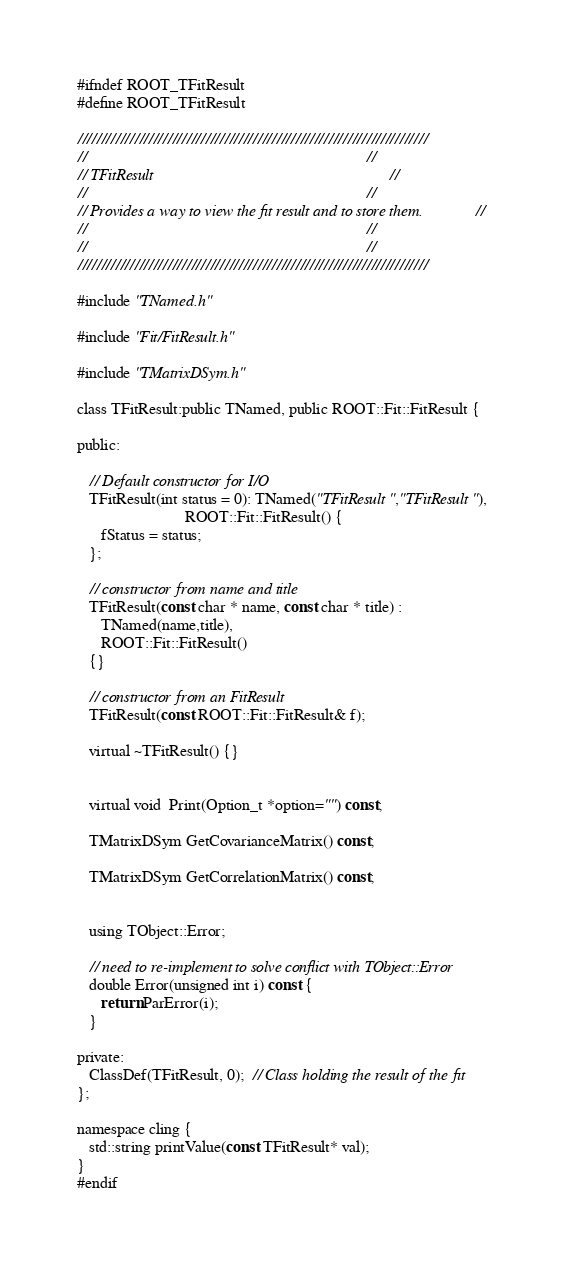<code> <loc_0><loc_0><loc_500><loc_500><_C_>#ifndef ROOT_TFitResult
#define ROOT_TFitResult

//////////////////////////////////////////////////////////////////////////
//                                                                      //
// TFitResult                                                           //
//                                                                      //
// Provides a way to view the fit result and to store them.             //
//                                                                      //
//                                                                      //
//////////////////////////////////////////////////////////////////////////

#include "TNamed.h"

#include "Fit/FitResult.h"

#include "TMatrixDSym.h"

class TFitResult:public TNamed, public ROOT::Fit::FitResult {

public:

   // Default constructor for I/O
   TFitResult(int status = 0): TNamed("TFitResult","TFitResult"),
                           ROOT::Fit::FitResult() {
      fStatus = status;
   };

   // constructor from name and title
   TFitResult(const char * name, const char * title) :
      TNamed(name,title),
      ROOT::Fit::FitResult()
   {}

   // constructor from an FitResult
   TFitResult(const ROOT::Fit::FitResult& f);

   virtual ~TFitResult() {}


   virtual void  Print(Option_t *option="") const;

   TMatrixDSym GetCovarianceMatrix() const;

   TMatrixDSym GetCorrelationMatrix() const;


   using TObject::Error;

   // need to re-implement to solve conflict with TObject::Error
   double Error(unsigned int i) const {
      return ParError(i);
   }

private:
   ClassDef(TFitResult, 0);  // Class holding the result of the fit
};

namespace cling {
   std::string printValue(const TFitResult* val);
}
#endif
</code> 